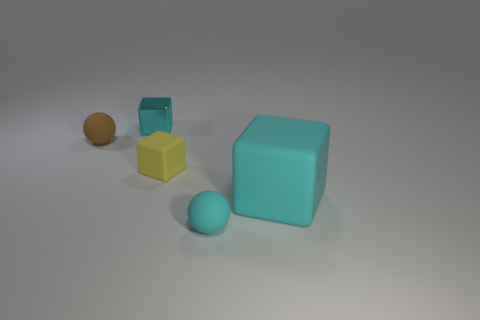Is there anything else that has the same size as the cyan matte cube?
Provide a short and direct response. No. Does the big thing have the same material as the tiny ball that is behind the yellow thing?
Your answer should be very brief. Yes. What color is the thing that is both on the right side of the small yellow matte block and left of the big object?
Offer a terse response. Cyan. What is the shape of the small cyan object that is on the right side of the yellow rubber thing?
Keep it short and to the point. Sphere. There is a cyan cube that is in front of the tiny cyan thing behind the cyan cube right of the yellow rubber object; what size is it?
Provide a succinct answer. Large. What number of small matte blocks are in front of the cyan object on the left side of the small yellow matte block?
Offer a very short reply. 1. There is a cyan object that is behind the small cyan ball and in front of the tiny brown rubber sphere; what is its size?
Provide a short and direct response. Large. How many shiny things are either big green objects or large cyan things?
Ensure brevity in your answer.  0. What is the material of the small cyan cube?
Offer a very short reply. Metal. There is a tiny cyan thing that is behind the block that is to the right of the tiny rubber ball that is right of the tiny brown sphere; what is it made of?
Make the answer very short. Metal. 